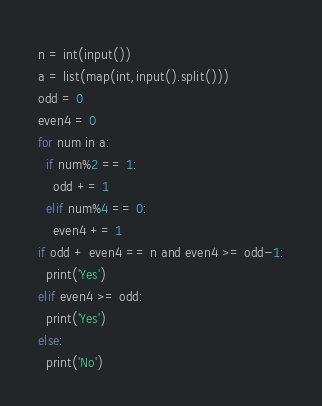<code> <loc_0><loc_0><loc_500><loc_500><_Python_>n = int(input())
a = list(map(int,input().split()))
odd = 0
even4 = 0
for num in a:
  if num%2 == 1:
    odd += 1
  elif num%4 == 0:
    even4 += 1
if odd + even4 == n and even4 >= odd-1:
  print('Yes')
elif even4 >= odd:
  print('Yes')
else:
  print('No')</code> 